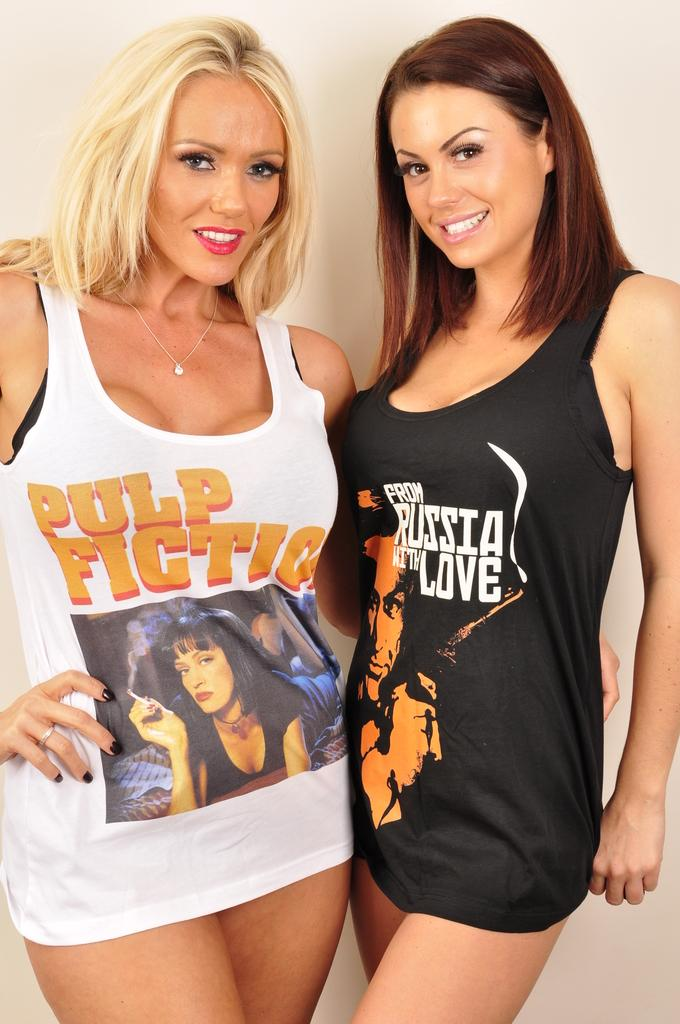Provide a one-sentence caption for the provided image. Two women are wearing shirts that say Pulp Fiction and From Russia with Love. 